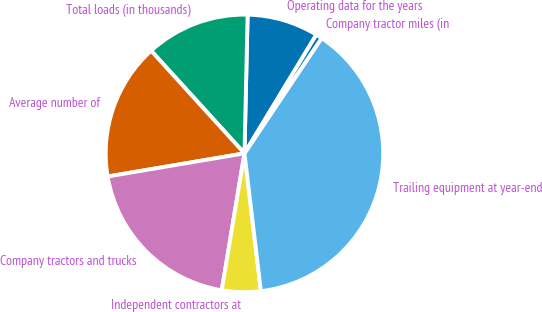Convert chart. <chart><loc_0><loc_0><loc_500><loc_500><pie_chart><fcel>Operating data for the years<fcel>Total loads (in thousands)<fcel>Average number of<fcel>Company tractors and trucks<fcel>Independent contractors at<fcel>Trailing equipment at year-end<fcel>Company tractor miles (in<nl><fcel>8.31%<fcel>12.11%<fcel>15.92%<fcel>19.72%<fcel>4.51%<fcel>38.73%<fcel>0.71%<nl></chart> 